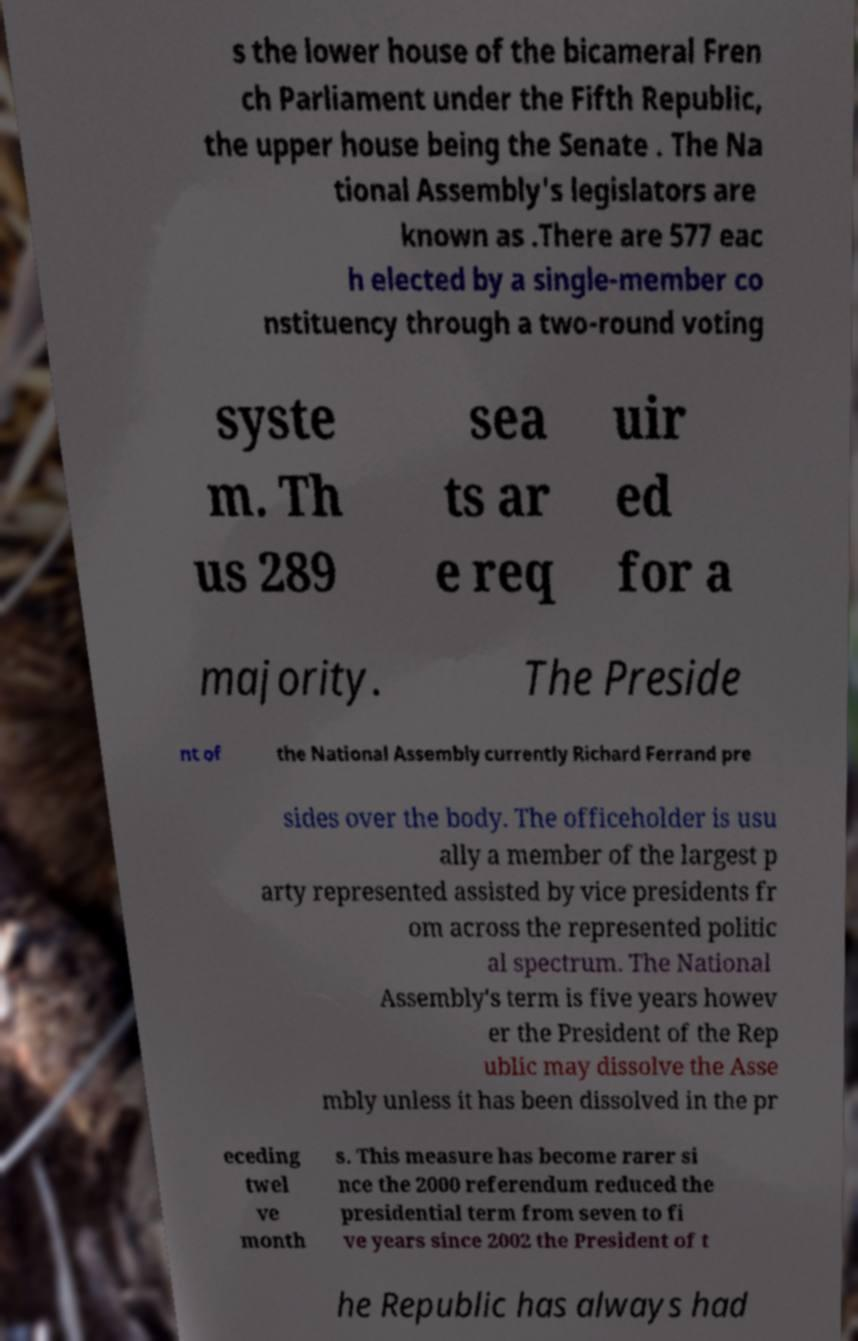I need the written content from this picture converted into text. Can you do that? s the lower house of the bicameral Fren ch Parliament under the Fifth Republic, the upper house being the Senate . The Na tional Assembly's legislators are known as .There are 577 eac h elected by a single-member co nstituency through a two-round voting syste m. Th us 289 sea ts ar e req uir ed for a majority. The Preside nt of the National Assembly currently Richard Ferrand pre sides over the body. The officeholder is usu ally a member of the largest p arty represented assisted by vice presidents fr om across the represented politic al spectrum. The National Assembly's term is five years howev er the President of the Rep ublic may dissolve the Asse mbly unless it has been dissolved in the pr eceding twel ve month s. This measure has become rarer si nce the 2000 referendum reduced the presidential term from seven to fi ve years since 2002 the President of t he Republic has always had 